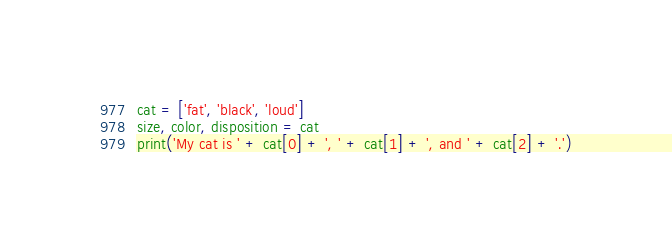<code> <loc_0><loc_0><loc_500><loc_500><_Python_>cat = ['fat', 'black', 'loud']
size, color, disposition = cat
print('My cat is ' + cat[0] + ', ' + cat[1] + ', and ' + cat[2] + '.')</code> 